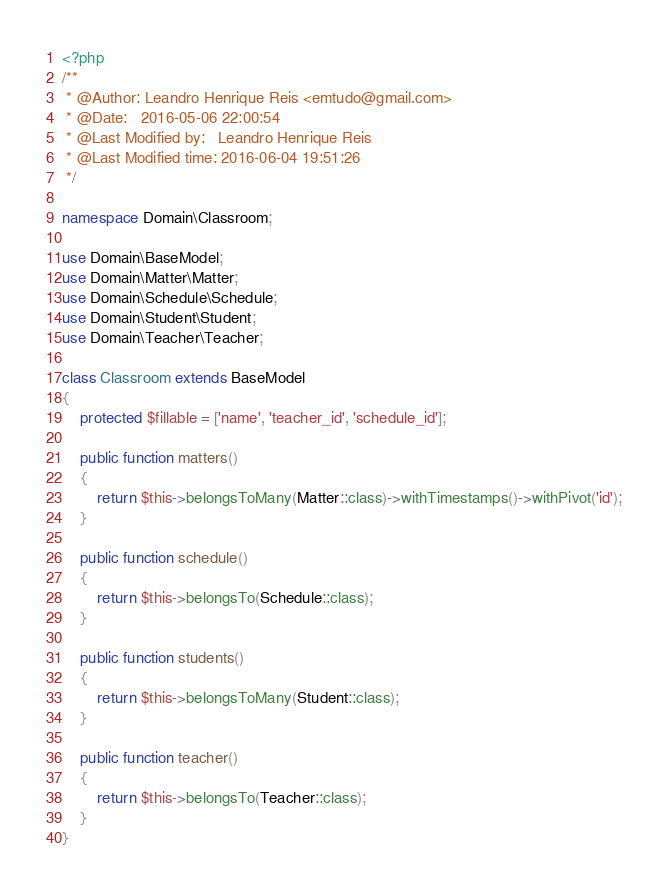<code> <loc_0><loc_0><loc_500><loc_500><_PHP_><?php
/**
 * @Author: Leandro Henrique Reis <emtudo@gmail.com>
 * @Date:   2016-05-06 22:00:54
 * @Last Modified by:   Leandro Henrique Reis
 * @Last Modified time: 2016-06-04 19:51:26
 */

namespace Domain\Classroom;

use Domain\BaseModel;
use Domain\Matter\Matter;
use Domain\Schedule\Schedule;
use Domain\Student\Student;
use Domain\Teacher\Teacher;

class Classroom extends BaseModel
{
    protected $fillable = ['name', 'teacher_id', 'schedule_id'];

    public function matters()
    {
        return $this->belongsToMany(Matter::class)->withTimestamps()->withPivot('id');
    }

    public function schedule()
    {
        return $this->belongsTo(Schedule::class);
    }

    public function students()
    {
        return $this->belongsToMany(Student::class);
    }

    public function teacher()
    {
        return $this->belongsTo(Teacher::class);
    }
}
</code> 